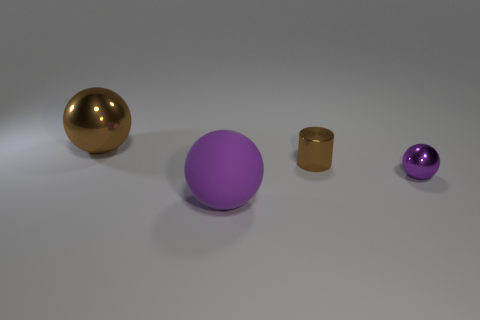Add 3 small brown shiny cylinders. How many objects exist? 7 Subtract all spheres. How many objects are left? 1 Subtract all small brown things. Subtract all small green metallic cubes. How many objects are left? 3 Add 3 brown shiny things. How many brown shiny things are left? 5 Add 1 tiny green shiny balls. How many tiny green shiny balls exist? 1 Subtract 0 gray cylinders. How many objects are left? 4 